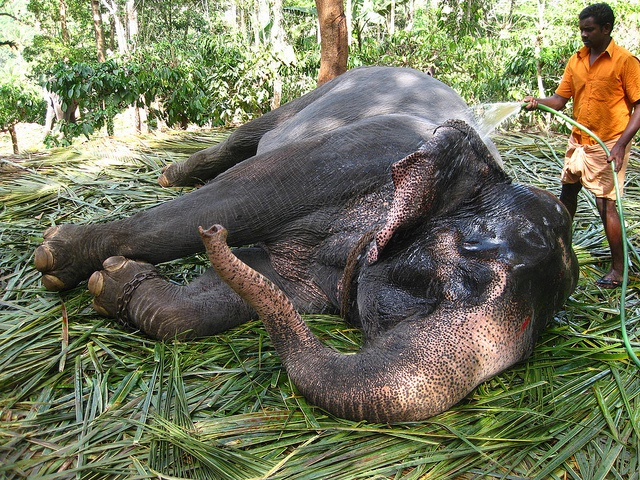Describe the objects in this image and their specific colors. I can see elephant in lightgreen, gray, black, darkgray, and darkgreen tones and people in lightgreen, black, red, orange, and brown tones in this image. 